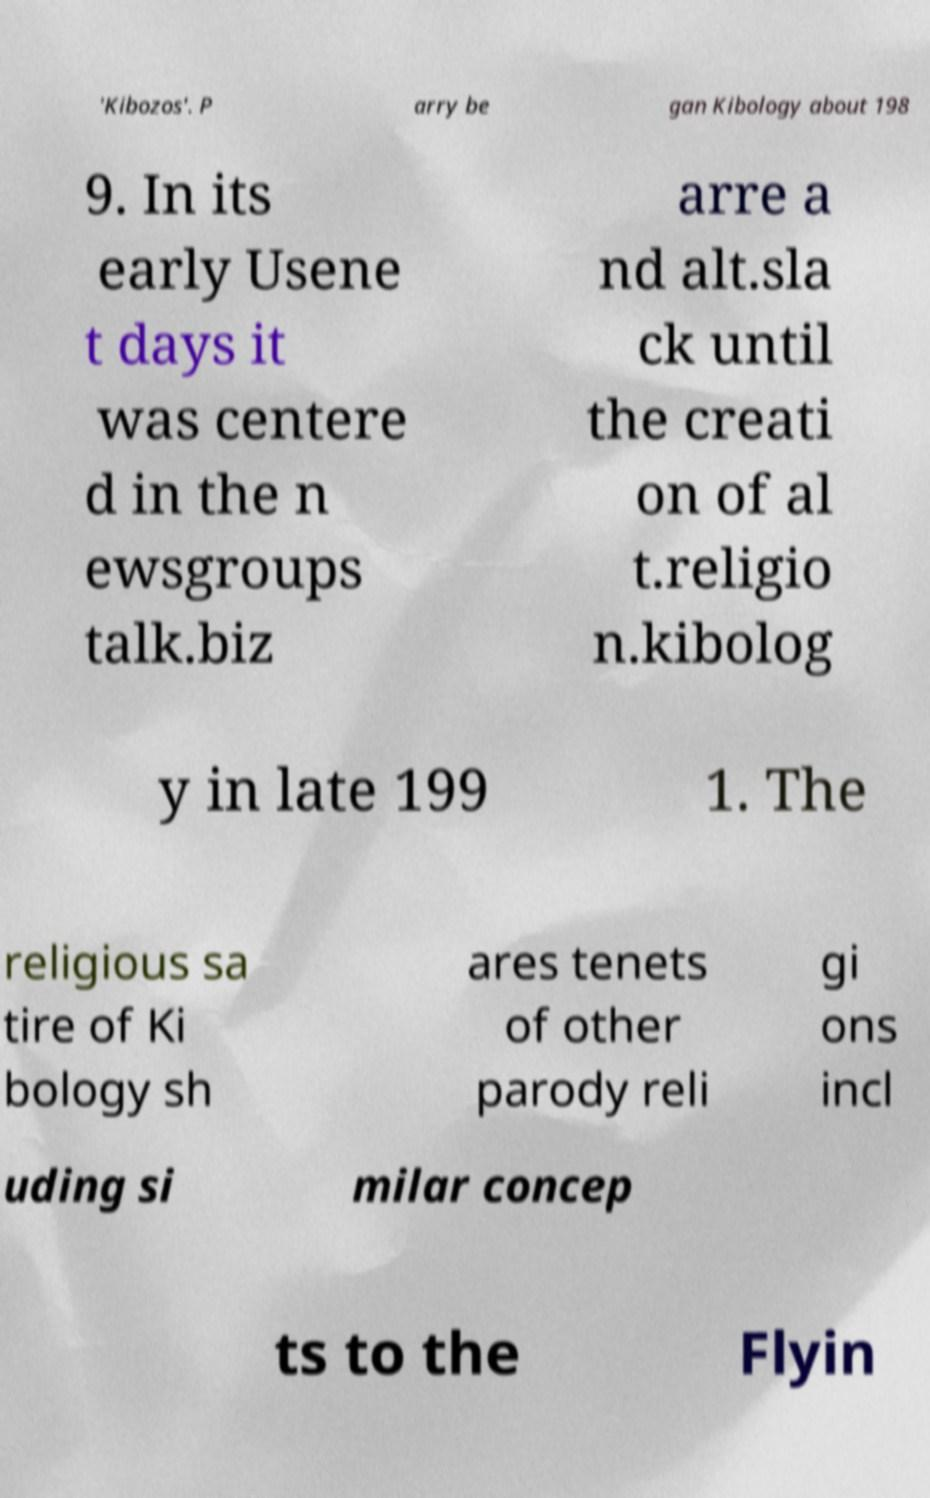There's text embedded in this image that I need extracted. Can you transcribe it verbatim? 'Kibozos'. P arry be gan Kibology about 198 9. In its early Usene t days it was centere d in the n ewsgroups talk.biz arre a nd alt.sla ck until the creati on of al t.religio n.kibolog y in late 199 1. The religious sa tire of Ki bology sh ares tenets of other parody reli gi ons incl uding si milar concep ts to the Flyin 